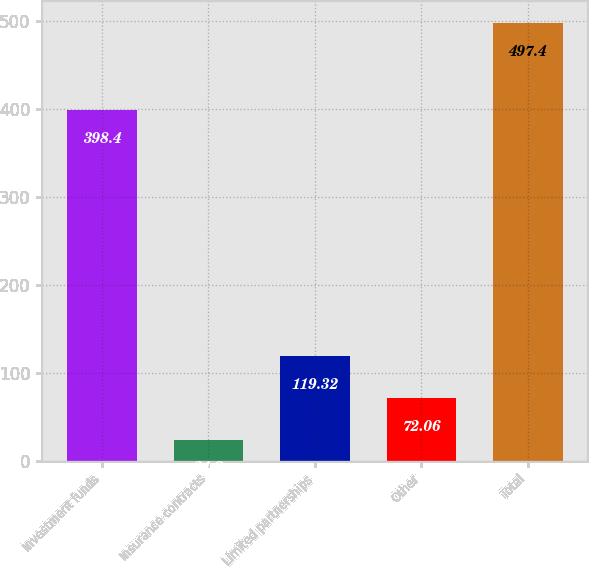<chart> <loc_0><loc_0><loc_500><loc_500><bar_chart><fcel>Investment funds<fcel>Insurance contracts<fcel>Limited partnerships<fcel>Other<fcel>Total<nl><fcel>398.4<fcel>24.8<fcel>119.32<fcel>72.06<fcel>497.4<nl></chart> 